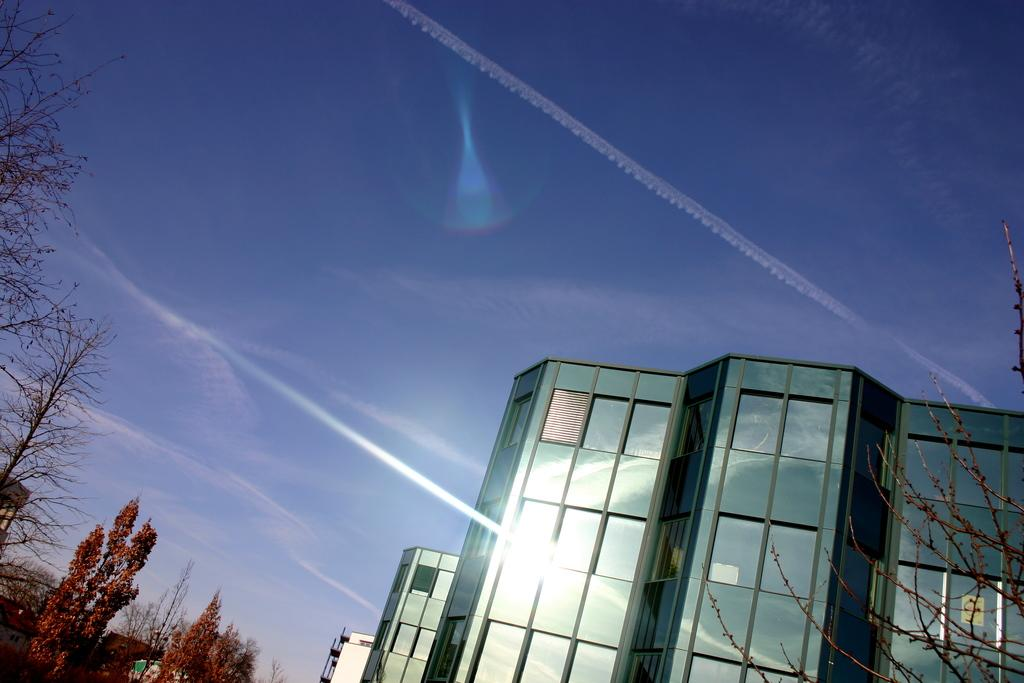What type of structures can be seen in the image? There are buildings in the image. What is located to the left in the image? There are trees to the left in the image. What is visible at the top of the image? The sky is visible at the top of the image. Can you tell me how many hens are perched on the buildings in the image? There are no hens present in the image; it features buildings, trees, and the sky. What type of bead is used to decorate the trees in the image? There are no beads present in the image; it features buildings, trees, and the sky. 